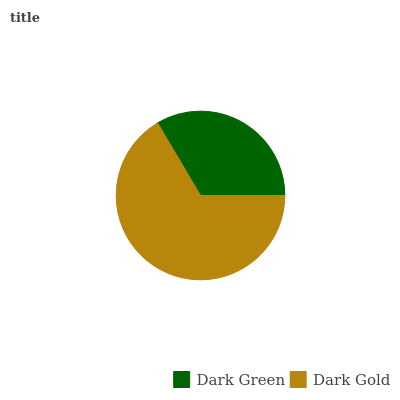Is Dark Green the minimum?
Answer yes or no. Yes. Is Dark Gold the maximum?
Answer yes or no. Yes. Is Dark Gold the minimum?
Answer yes or no. No. Is Dark Gold greater than Dark Green?
Answer yes or no. Yes. Is Dark Green less than Dark Gold?
Answer yes or no. Yes. Is Dark Green greater than Dark Gold?
Answer yes or no. No. Is Dark Gold less than Dark Green?
Answer yes or no. No. Is Dark Gold the high median?
Answer yes or no. Yes. Is Dark Green the low median?
Answer yes or no. Yes. Is Dark Green the high median?
Answer yes or no. No. Is Dark Gold the low median?
Answer yes or no. No. 